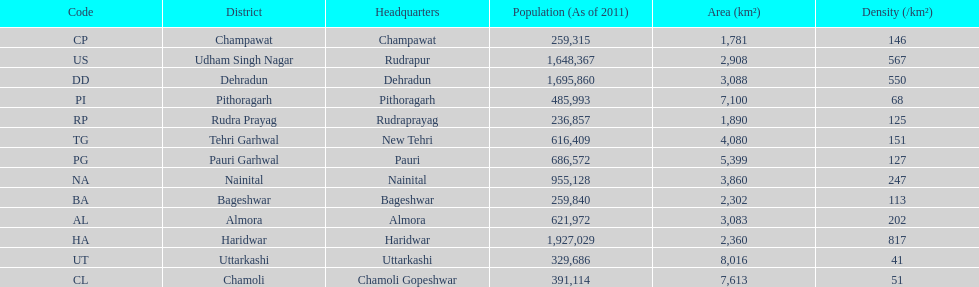How many total districts are there in this area? 13. Can you parse all the data within this table? {'header': ['Code', 'District', 'Headquarters', 'Population (As of 2011)', 'Area (km²)', 'Density (/km²)'], 'rows': [['CP', 'Champawat', 'Champawat', '259,315', '1,781', '146'], ['US', 'Udham Singh Nagar', 'Rudrapur', '1,648,367', '2,908', '567'], ['DD', 'Dehradun', 'Dehradun', '1,695,860', '3,088', '550'], ['PI', 'Pithoragarh', 'Pithoragarh', '485,993', '7,100', '68'], ['RP', 'Rudra Prayag', 'Rudraprayag', '236,857', '1,890', '125'], ['TG', 'Tehri Garhwal', 'New Tehri', '616,409', '4,080', '151'], ['PG', 'Pauri Garhwal', 'Pauri', '686,572', '5,399', '127'], ['NA', 'Nainital', 'Nainital', '955,128', '3,860', '247'], ['BA', 'Bageshwar', 'Bageshwar', '259,840', '2,302', '113'], ['AL', 'Almora', 'Almora', '621,972', '3,083', '202'], ['HA', 'Haridwar', 'Haridwar', '1,927,029', '2,360', '817'], ['UT', 'Uttarkashi', 'Uttarkashi', '329,686', '8,016', '41'], ['CL', 'Chamoli', 'Chamoli Gopeshwar', '391,114', '7,613', '51']]} 